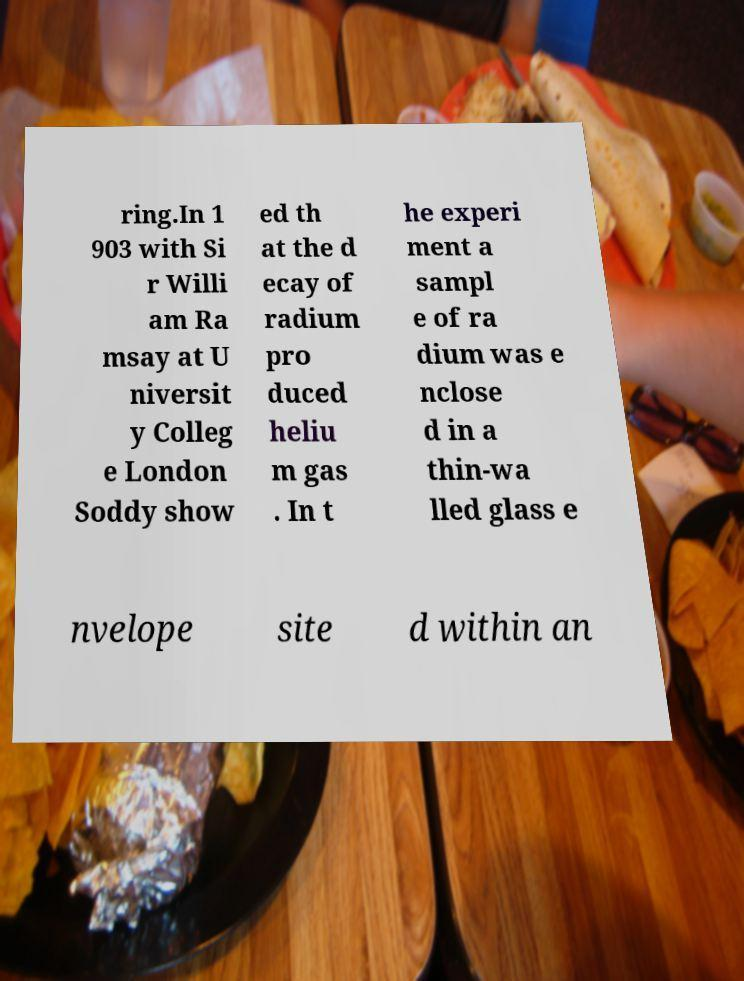Could you assist in decoding the text presented in this image and type it out clearly? ring.In 1 903 with Si r Willi am Ra msay at U niversit y Colleg e London Soddy show ed th at the d ecay of radium pro duced heliu m gas . In t he experi ment a sampl e of ra dium was e nclose d in a thin-wa lled glass e nvelope site d within an 